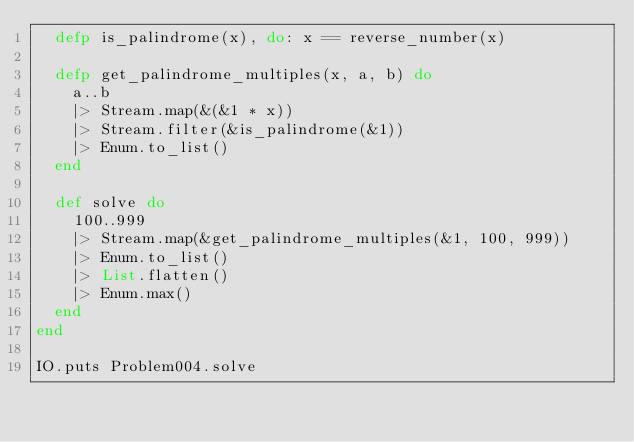Convert code to text. <code><loc_0><loc_0><loc_500><loc_500><_Elixir_>  defp is_palindrome(x), do: x == reverse_number(x)
  
  defp get_palindrome_multiples(x, a, b) do
    a..b
    |> Stream.map(&(&1 * x))
    |> Stream.filter(&is_palindrome(&1))
    |> Enum.to_list()
  end

  def solve do
    100..999
    |> Stream.map(&get_palindrome_multiples(&1, 100, 999))
    |> Enum.to_list()
    |> List.flatten()
    |> Enum.max()
  end
end

IO.puts Problem004.solve
</code> 